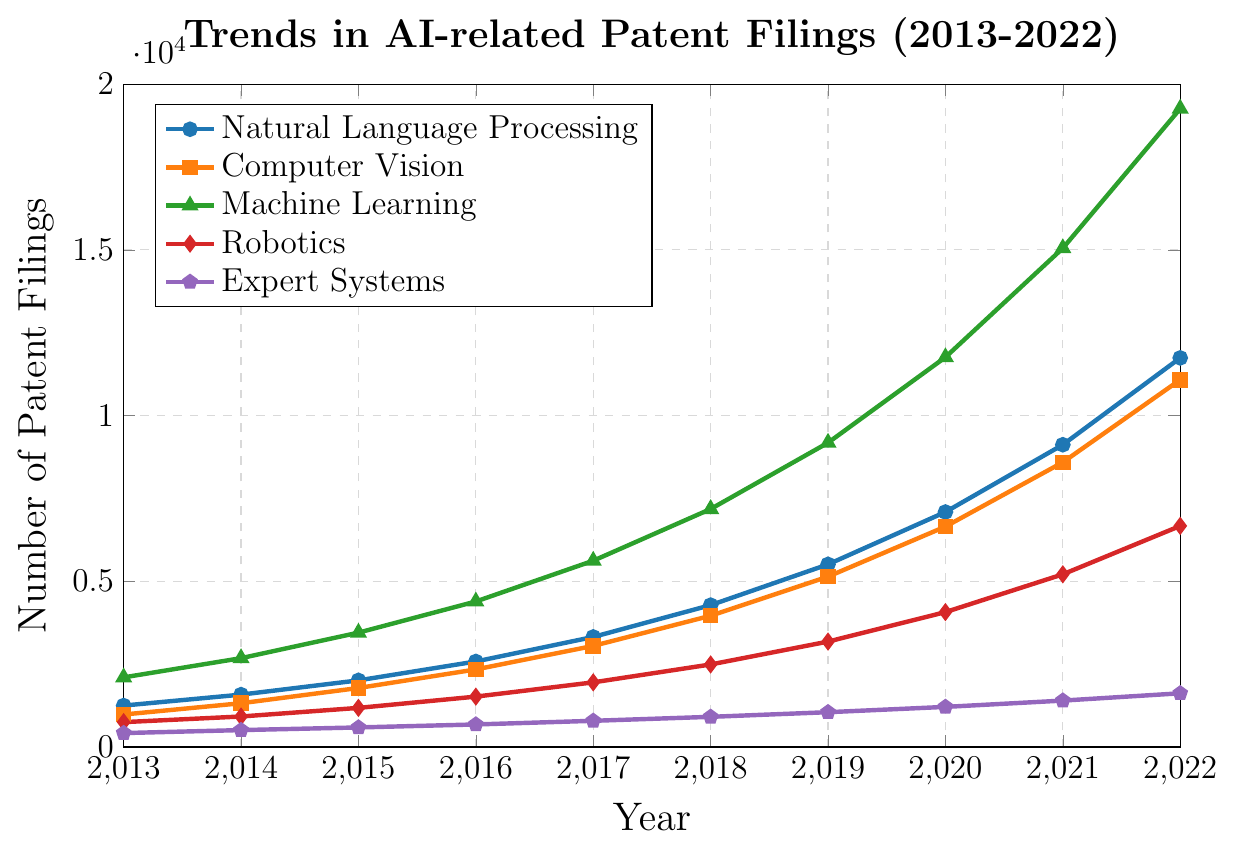What was the trend in patent filings for Natural Language Processing (NLP) from 2013 to 2022? To determine the trend, we observe the upward or downward shifts in the number of patent filings from 2013 to 2022 in the NLP category. The numbers show a consistent increase from 1250 in 2013 to 11740 in 2022.
Answer: Increasing Which year showed the largest increase in Machine Learning patent filings compared to the previous year? We need to calculate the year-over-year differences for Machine Learning filings and find the maximum. The differences are: 580 (2014), 770 (2015), 940 (2016), 1230 (2017), 1560 (2018), 2000 (2019), 2580 (2020), 3290 (2021), and 4210 (2022). The largest increase was from 15050 in 2021 to 19260 in 2022, an increase of 4210.
Answer: 2022 Between which consecutive years did Robotics filings see the smallest increase? To find this, we calculate the differences between consecutive years for Robotics filings. The differences are: 170 (2014), 260 (2015), 340 (2016), 430 (2017), 540 (2018), 690 (2019), 890 (2020), 1140 (2021), and 1460 (2022). The smallest increase is 170, occurring between 2013 and 2014.
Answer: 2013-2014 In 2020, how many more patent filings were there in Machine Learning compared to Expert Systems? Find the number of filings for Machine Learning and Expert Systems in 2020, and then calculate the difference: 11760 (Machine Learning) - 1210 (Expert Systems) = 10550.
Answer: 10550 Which AI technology had the second-highest number of patent filings in 2019? We review the number of filings for each technology in 2019 and rank them: Machine Learning (9180), Natural Language Processing (5510), Computer Vision (5140), Robotics (3180), and Expert Systems (1050). The second-highest is Natural Language Processing with 5510 filings.
Answer: Natural Language Processing What is the average number of Natural Language Processing patent filings over the decade? Sum the NLP filings from 2013 to 2022 and divide by 10: (1250 + 1580 + 2010 + 2580 + 3320 + 4280 + 5510 + 7090 + 9120 + 11740) / 10 = 48980 / 10 = 4898.
Answer: 4898 In 2020, which AI technology saw the largest number of patent filings? From the 2020 data, compare each technology's filings: Natural Language Processing (7090), Computer Vision (6650), Machine Learning (11760), Robotics (4070), Expert Systems (1210). Machine Learning had the largest number with 11760 filings.
Answer: Machine Learning From 2013 to 2022, which AI technology consistently had the lowest number of patent filings every year? Review each year's data for all technologies to identify the one with the lowest filings throughout. Expert Systems consistently had the lowest number of filings each year.
Answer: Expert Systems By how much did the number of Computer Vision patent filings increase from 2013 to 2022? Subtract the number of Computer Vision filings in 2013 from those in 2022: 11080 (2022) - 980 (2013) = 10100.
Answer: 10100 